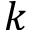<formula> <loc_0><loc_0><loc_500><loc_500>k</formula> 